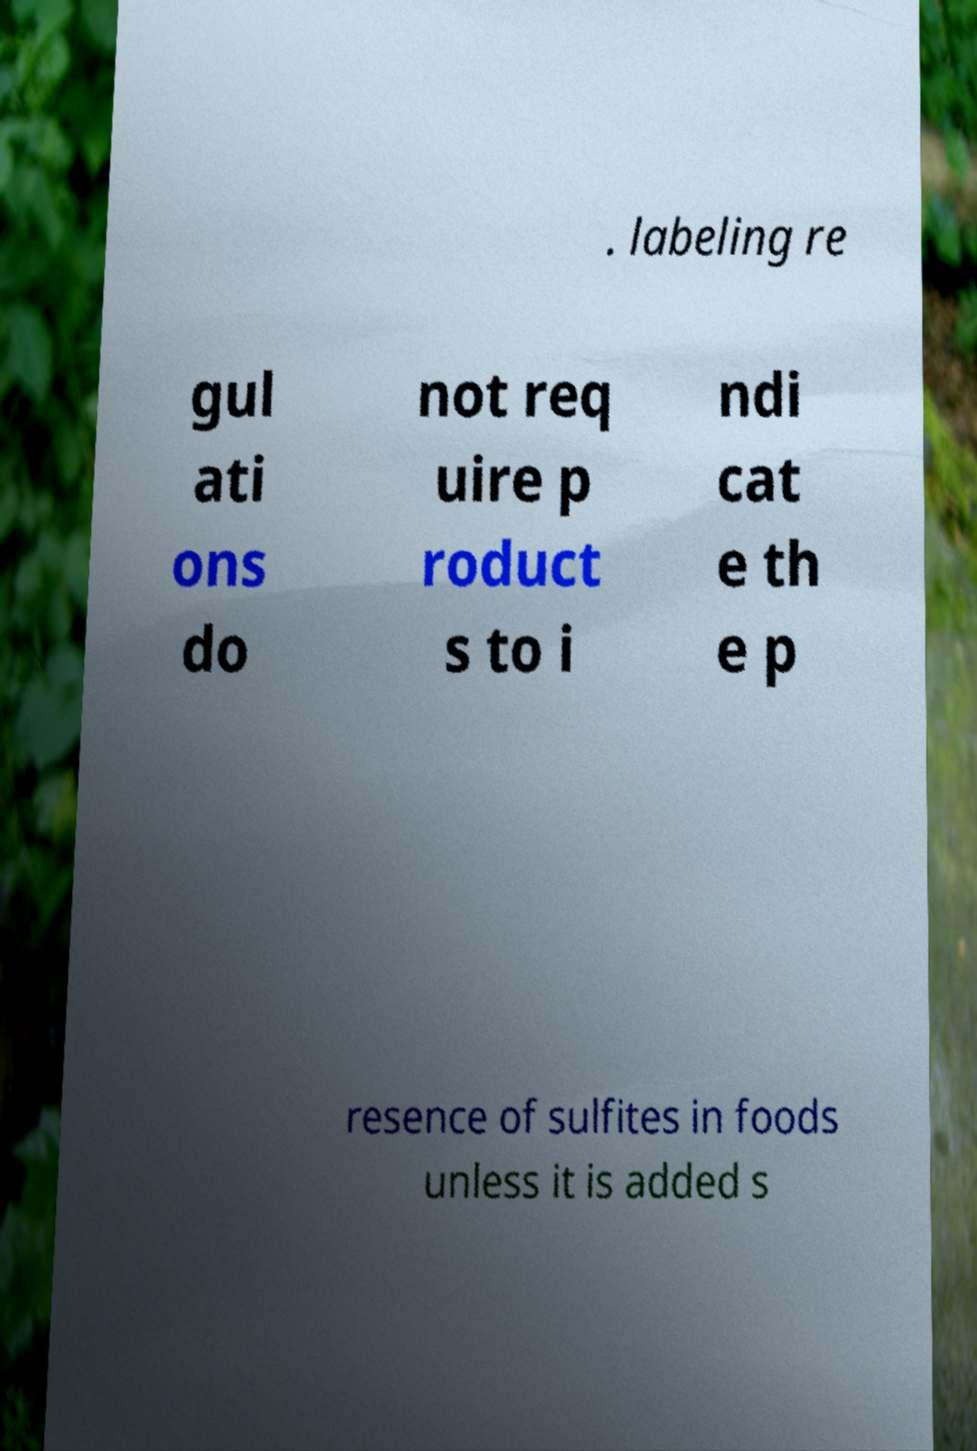Can you read and provide the text displayed in the image?This photo seems to have some interesting text. Can you extract and type it out for me? . labeling re gul ati ons do not req uire p roduct s to i ndi cat e th e p resence of sulfites in foods unless it is added s 